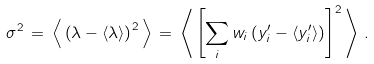Convert formula to latex. <formula><loc_0><loc_0><loc_500><loc_500>\sigma ^ { 2 } \, = \, \left \langle \, \left ( \lambda - \langle \lambda \rangle \right ) ^ { 2 } \, \right \rangle \, = \, \left \langle \, \left [ \sum _ { i } w _ { i } \left ( y ^ { \prime } _ { i } - \left \langle y ^ { \prime } _ { i } \right \rangle \right ) \right ] ^ { 2 } \, \right \rangle \, .</formula> 